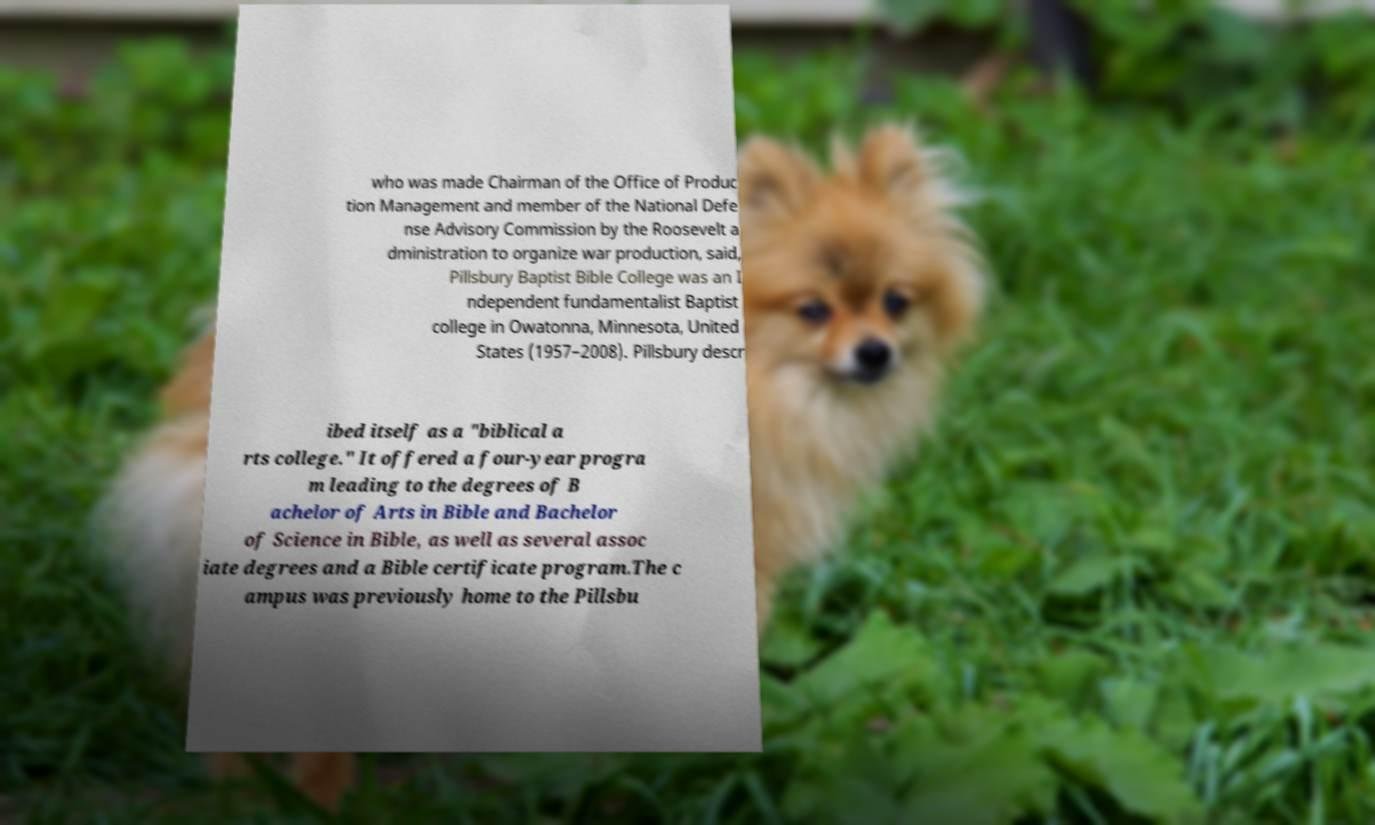Please read and relay the text visible in this image. What does it say? who was made Chairman of the Office of Produc tion Management and member of the National Defe nse Advisory Commission by the Roosevelt a dministration to organize war production, said, Pillsbury Baptist Bible College was an I ndependent fundamentalist Baptist college in Owatonna, Minnesota, United States (1957–2008). Pillsbury descr ibed itself as a "biblical a rts college." It offered a four-year progra m leading to the degrees of B achelor of Arts in Bible and Bachelor of Science in Bible, as well as several assoc iate degrees and a Bible certificate program.The c ampus was previously home to the Pillsbu 